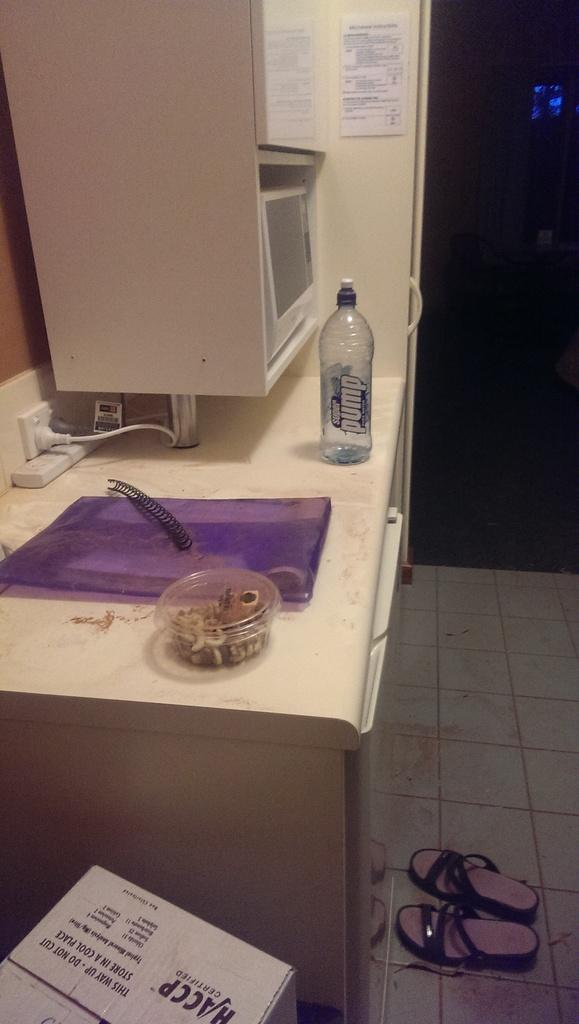<image>
Summarize the visual content of the image. The counter has a purple mat and a pump water bottle on it. 